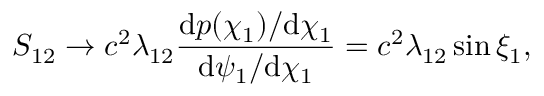Convert formula to latex. <formula><loc_0><loc_0><loc_500><loc_500>S _ { 1 2 } \rightarrow c ^ { 2 } \lambda _ { 1 2 } \frac { \mathrm d p ( \chi _ { 1 } ) / \mathrm d \chi _ { 1 } } { \mathrm d \psi _ { 1 } / \mathrm d \chi _ { 1 } } = c ^ { 2 } \lambda _ { 1 2 } \sin \xi _ { 1 } ,</formula> 